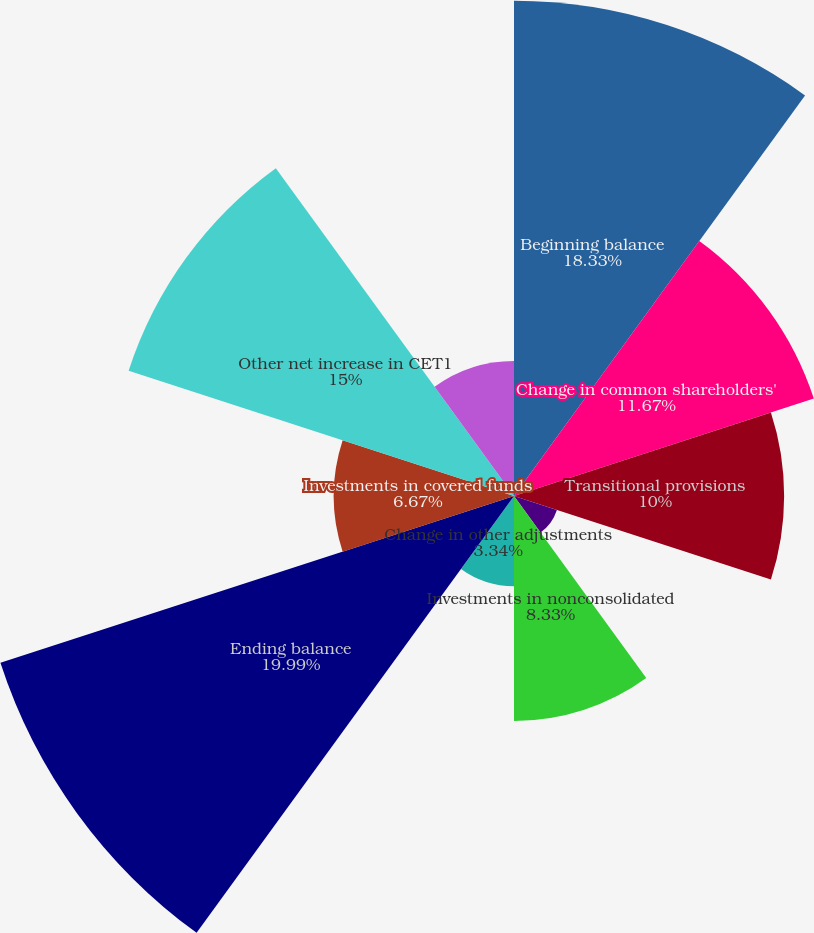<chart> <loc_0><loc_0><loc_500><loc_500><pie_chart><fcel>Beginning balance<fcel>Change in common shareholders'<fcel>Transitional provisions<fcel>Goodwill and identifiable<fcel>Investments in nonconsolidated<fcel>Change in other adjustments<fcel>Ending balance<fcel>Investments in covered funds<fcel>Other net increase in CET1<fcel>Redesignation of junior<nl><fcel>18.33%<fcel>11.67%<fcel>10.0%<fcel>1.67%<fcel>8.33%<fcel>3.34%<fcel>19.99%<fcel>6.67%<fcel>15.0%<fcel>5.0%<nl></chart> 